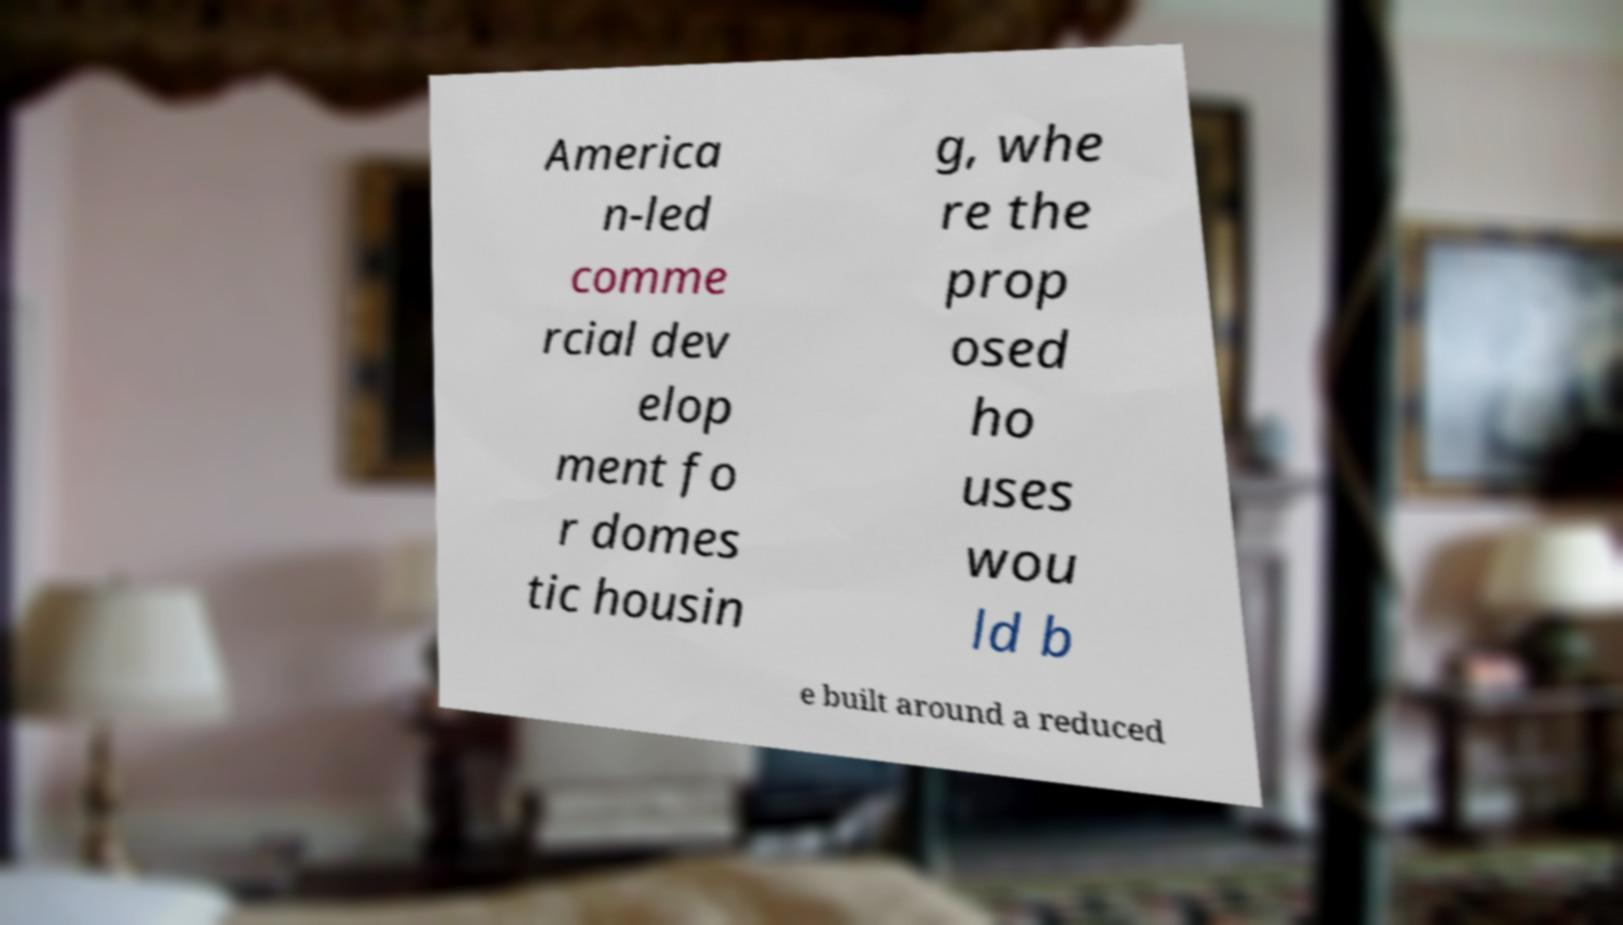Could you extract and type out the text from this image? America n-led comme rcial dev elop ment fo r domes tic housin g, whe re the prop osed ho uses wou ld b e built around a reduced 